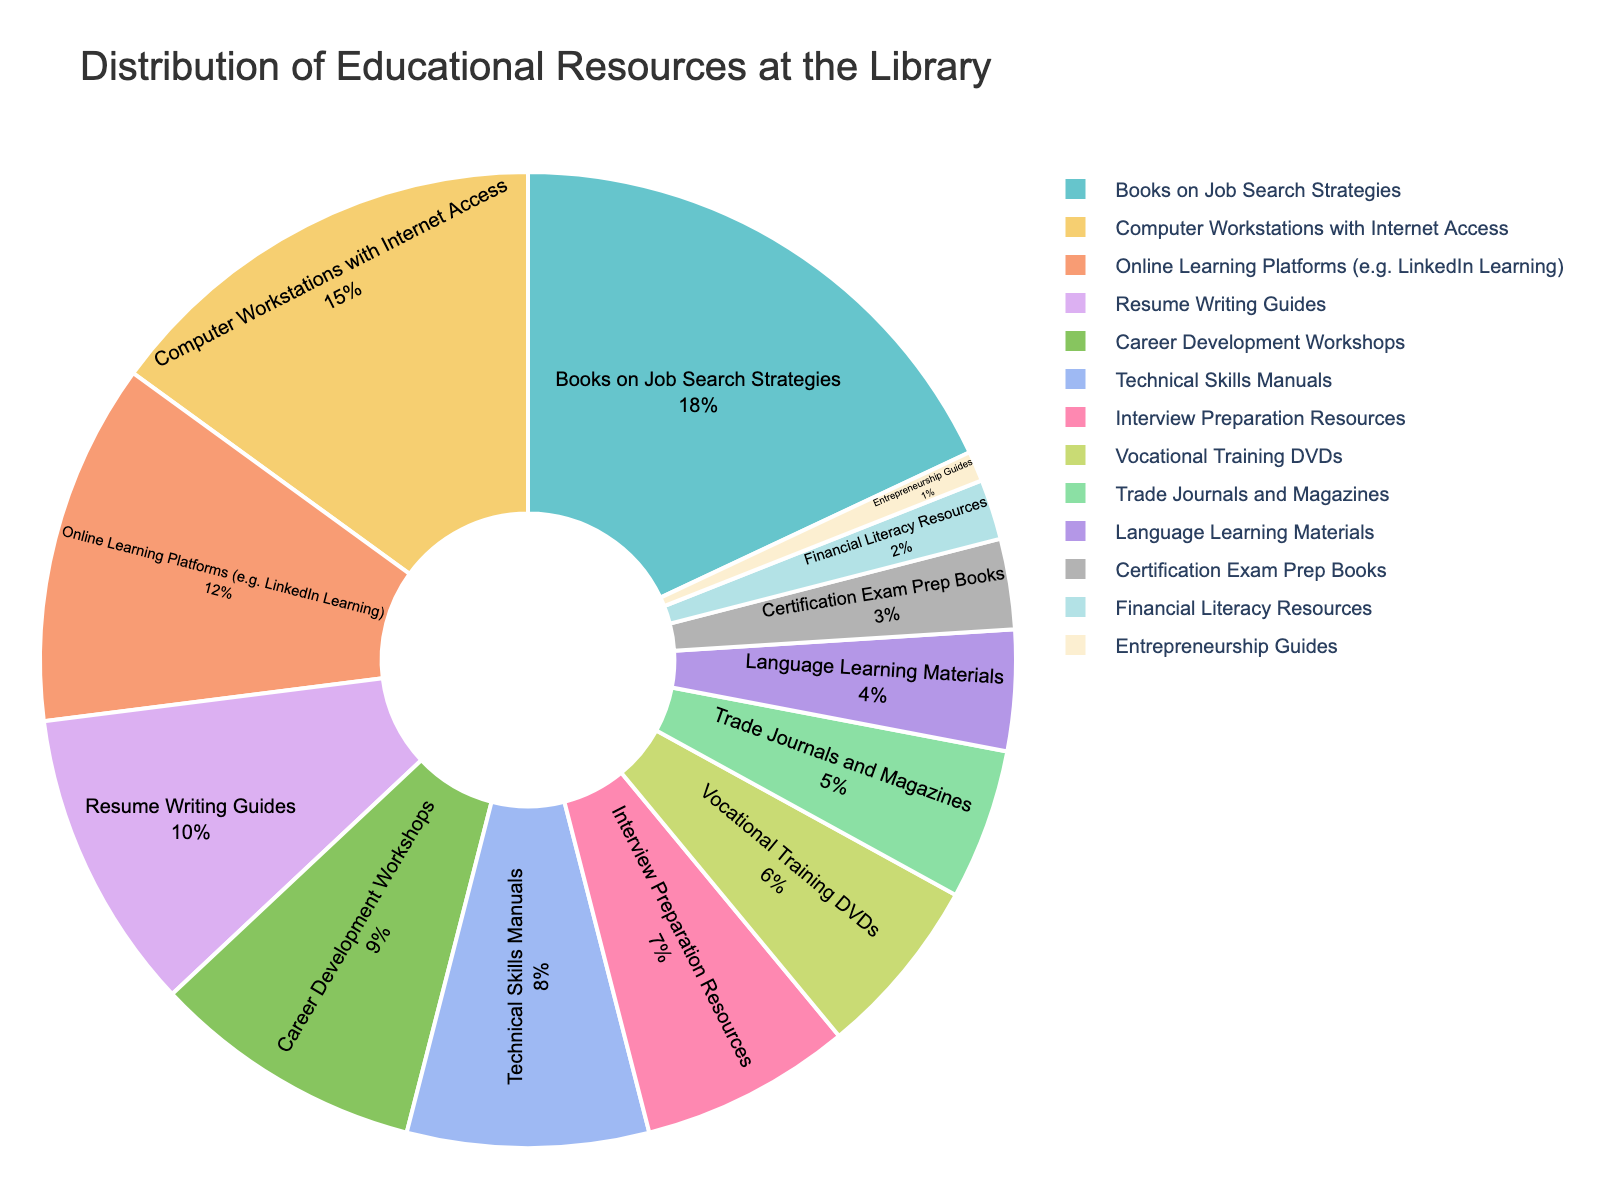What percentage of the library's resources is dedicated to Interview Preparation Resources and Certification Exam Prep Books combined? First, find the percentage of Interview Preparation Resources (7%) and Certification Exam Prep Books (3%). Then, add them together: 7% + 3% = 10%.
Answer: 10% Which resource category has the highest percentage? Look for the category with the largest segment in the pie chart. The segment labeled "Books on Job Search Strategies" has the highest percentage of 18%.
Answer: Books on Job Search Strategies Is the percentage of Computer Workstations with Internet Access greater than the percentage of Trade Journals and Magazines? Identify the percentages of both categories from the chart. Computer Workstations with Internet Access has 15%, and Trade Journals and Magazines have 5%. Since 15% is greater than 5%, the answer is yes.
Answer: Yes Which resource category is allocated the least percentage? Find the category with the smallest segment in the chart. The smallest segment belongs to "Entrepreneurship Guides" with 1%.
Answer: Entrepreneurship Guides How many resource categories have a percentage less than 6%? Identify the categories with percentages less than 6%: Vocational Training DVDs (6%), Trade Journals and Magazines (5%), Language Learning Materials (4%), Certification Exam Prep Books (3%), Financial Literacy Resources (2%), and Entrepreneurship Guides (1%). Count these categories: there are six of them.
Answer: 6 What are the combined percentages of Resume Writing Guides and Career Development Workshops? Find the percentages of both categories: Resume Writing Guides (10%) and Career Development Workshops (9%). Add these percentages together: 10% + 9% = 19%.
Answer: 19% Compare the percentage of Technical Skills Manuals to Online Learning Platforms. Which is greater and by how much? Compare the percentages of Technical Skills Manuals (8%) and Online Learning Platforms (12%). Subtract the smaller percentage from the larger: 12% - 8% = 4%. Online Learning Platforms are greater by 4%.
Answer: Online Learning Platforms by 4% What is the difference in percentage points between Books on Job Search Strategies and Career Development Workshops? Find the percentages for both categories: Books on Job Search Strategies (18%) and Career Development Workshops (9%). Subtract the smaller percentage from the larger: 18% - 9% = 9%.
Answer: 9% 